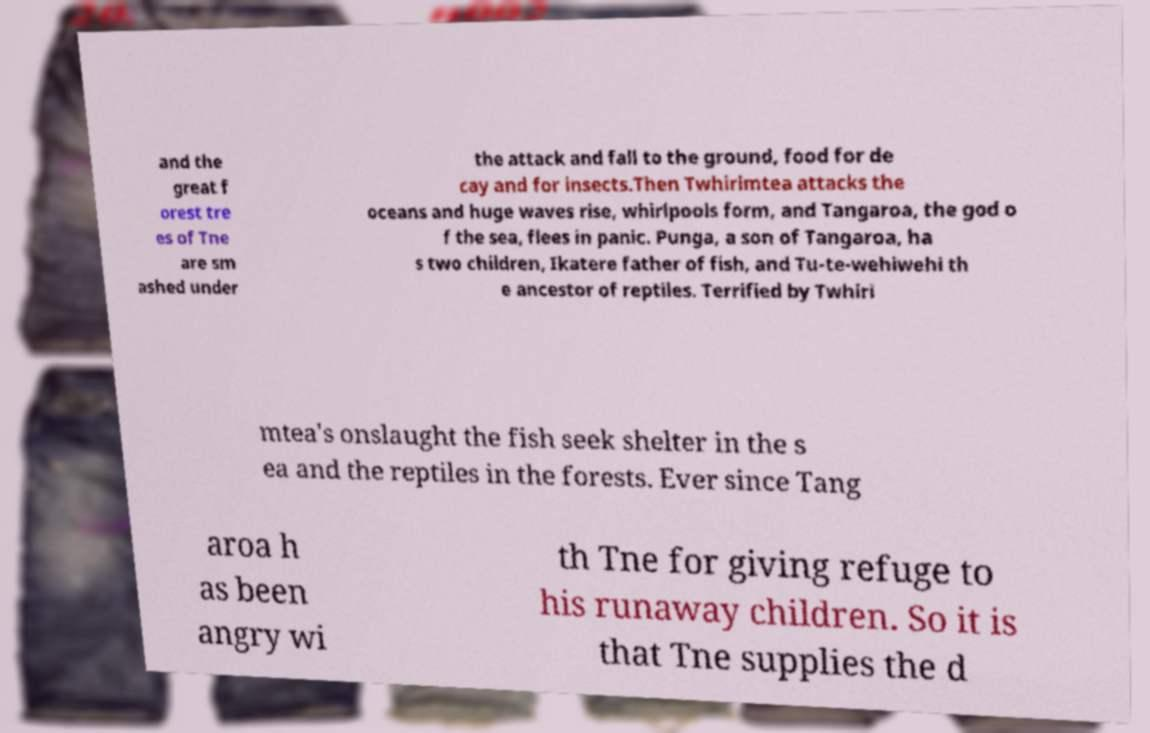Please read and relay the text visible in this image. What does it say? and the great f orest tre es of Tne are sm ashed under the attack and fall to the ground, food for de cay and for insects.Then Twhirimtea attacks the oceans and huge waves rise, whirlpools form, and Tangaroa, the god o f the sea, flees in panic. Punga, a son of Tangaroa, ha s two children, Ikatere father of fish, and Tu-te-wehiwehi th e ancestor of reptiles. Terrified by Twhiri mtea's onslaught the fish seek shelter in the s ea and the reptiles in the forests. Ever since Tang aroa h as been angry wi th Tne for giving refuge to his runaway children. So it is that Tne supplies the d 